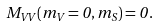Convert formula to latex. <formula><loc_0><loc_0><loc_500><loc_500>M _ { V V } ( m _ { V } = 0 , m _ { S } ) = 0 \, .</formula> 